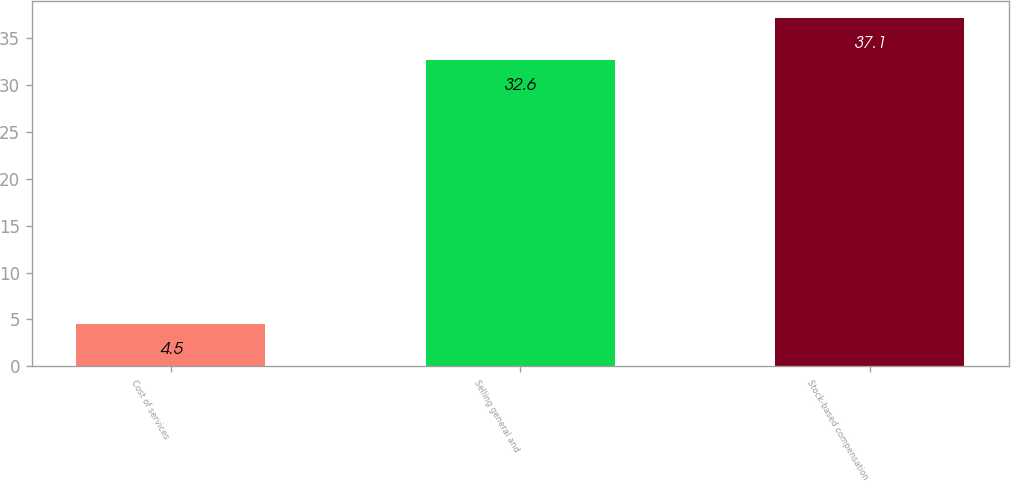<chart> <loc_0><loc_0><loc_500><loc_500><bar_chart><fcel>Cost of services<fcel>Selling general and<fcel>Stock-based compensation<nl><fcel>4.5<fcel>32.6<fcel>37.1<nl></chart> 